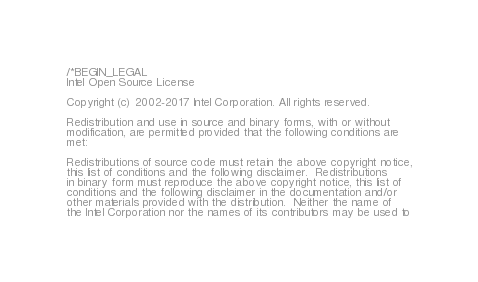<code> <loc_0><loc_0><loc_500><loc_500><_C++_>/*BEGIN_LEGAL 
Intel Open Source License 

Copyright (c) 2002-2017 Intel Corporation. All rights reserved.
 
Redistribution and use in source and binary forms, with or without
modification, are permitted provided that the following conditions are
met:

Redistributions of source code must retain the above copyright notice,
this list of conditions and the following disclaimer.  Redistributions
in binary form must reproduce the above copyright notice, this list of
conditions and the following disclaimer in the documentation and/or
other materials provided with the distribution.  Neither the name of
the Intel Corporation nor the names of its contributors may be used to</code> 